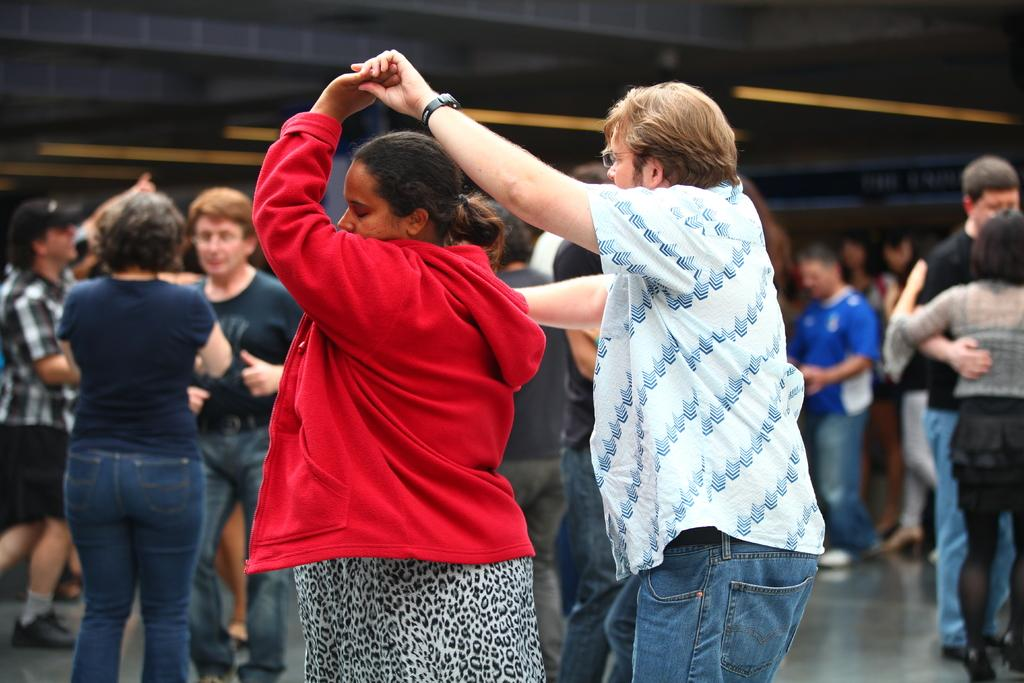What is the main subject of the image? The main subject of the image is a group of people. Where are the people located in the image? The people are on the floor in the image. What else can be seen in the image besides the people? There are objects present in the image. How many pets are visible in the image? There are no pets present in the image; it features a group of people on the floor with objects. 